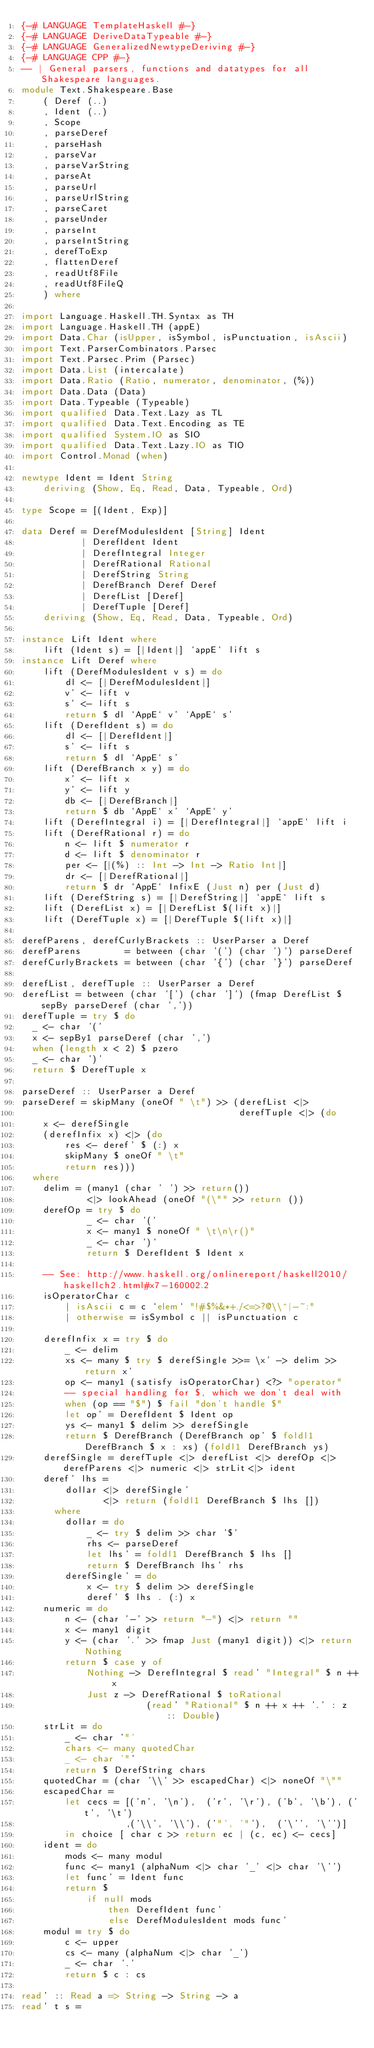<code> <loc_0><loc_0><loc_500><loc_500><_Haskell_>{-# LANGUAGE TemplateHaskell #-}
{-# LANGUAGE DeriveDataTypeable #-}
{-# LANGUAGE GeneralizedNewtypeDeriving #-}
{-# LANGUAGE CPP #-}
-- | General parsers, functions and datatypes for all Shakespeare languages.
module Text.Shakespeare.Base
    ( Deref (..)
    , Ident (..)
    , Scope
    , parseDeref
    , parseHash
    , parseVar
    , parseVarString
    , parseAt
    , parseUrl
    , parseUrlString
    , parseCaret
    , parseUnder
    , parseInt
    , parseIntString
    , derefToExp
    , flattenDeref
    , readUtf8File
    , readUtf8FileQ
    ) where

import Language.Haskell.TH.Syntax as TH
import Language.Haskell.TH (appE)
import Data.Char (isUpper, isSymbol, isPunctuation, isAscii)
import Text.ParserCombinators.Parsec
import Text.Parsec.Prim (Parsec)
import Data.List (intercalate)
import Data.Ratio (Ratio, numerator, denominator, (%))
import Data.Data (Data)
import Data.Typeable (Typeable)
import qualified Data.Text.Lazy as TL
import qualified Data.Text.Encoding as TE
import qualified System.IO as SIO
import qualified Data.Text.Lazy.IO as TIO
import Control.Monad (when)

newtype Ident = Ident String
    deriving (Show, Eq, Read, Data, Typeable, Ord)

type Scope = [(Ident, Exp)]

data Deref = DerefModulesIdent [String] Ident
           | DerefIdent Ident
           | DerefIntegral Integer
           | DerefRational Rational
           | DerefString String
           | DerefBranch Deref Deref
           | DerefList [Deref]
           | DerefTuple [Deref]
    deriving (Show, Eq, Read, Data, Typeable, Ord)

instance Lift Ident where
    lift (Ident s) = [|Ident|] `appE` lift s
instance Lift Deref where
    lift (DerefModulesIdent v s) = do
        dl <- [|DerefModulesIdent|]
        v' <- lift v
        s' <- lift s
        return $ dl `AppE` v' `AppE` s'
    lift (DerefIdent s) = do
        dl <- [|DerefIdent|]
        s' <- lift s
        return $ dl `AppE` s'
    lift (DerefBranch x y) = do
        x' <- lift x
        y' <- lift y
        db <- [|DerefBranch|]
        return $ db `AppE` x' `AppE` y'
    lift (DerefIntegral i) = [|DerefIntegral|] `appE` lift i
    lift (DerefRational r) = do
        n <- lift $ numerator r
        d <- lift $ denominator r
        per <- [|(%) :: Int -> Int -> Ratio Int|]
        dr <- [|DerefRational|]
        return $ dr `AppE` InfixE (Just n) per (Just d)
    lift (DerefString s) = [|DerefString|] `appE` lift s
    lift (DerefList x) = [|DerefList $(lift x)|]
    lift (DerefTuple x) = [|DerefTuple $(lift x)|]

derefParens, derefCurlyBrackets :: UserParser a Deref
derefParens        = between (char '(') (char ')') parseDeref
derefCurlyBrackets = between (char '{') (char '}') parseDeref

derefList, derefTuple :: UserParser a Deref
derefList = between (char '[') (char ']') (fmap DerefList $ sepBy parseDeref (char ','))
derefTuple = try $ do
  _ <- char '('
  x <- sepBy1 parseDeref (char ',')
  when (length x < 2) $ pzero
  _ <- char ')'
  return $ DerefTuple x

parseDeref :: UserParser a Deref
parseDeref = skipMany (oneOf " \t") >> (derefList <|>
                                        derefTuple <|> (do
    x <- derefSingle
    (derefInfix x) <|> (do
        res <- deref' $ (:) x
        skipMany $ oneOf " \t"
        return res)))
  where
    delim = (many1 (char ' ') >> return())
            <|> lookAhead (oneOf "(\"" >> return ())
    derefOp = try $ do
            _ <- char '('
            x <- many1 $ noneOf " \t\n\r()"
            _ <- char ')'
            return $ DerefIdent $ Ident x

    -- See: http://www.haskell.org/onlinereport/haskell2010/haskellch2.html#x7-160002.2
    isOperatorChar c
        | isAscii c = c `elem` "!#$%&*+./<=>?@\\^|-~:"
        | otherwise = isSymbol c || isPunctuation c

    derefInfix x = try $ do
        _ <- delim
        xs <- many $ try $ derefSingle >>= \x' -> delim >> return x'
        op <- many1 (satisfy isOperatorChar) <?> "operator"
        -- special handling for $, which we don't deal with
        when (op == "$") $ fail "don't handle $"
        let op' = DerefIdent $ Ident op
        ys <- many1 $ delim >> derefSingle
        return $ DerefBranch (DerefBranch op' $ foldl1 DerefBranch $ x : xs) (foldl1 DerefBranch ys)
    derefSingle = derefTuple <|> derefList <|> derefOp <|> derefParens <|> numeric <|> strLit<|> ident
    deref' lhs =
        dollar <|> derefSingle'
               <|> return (foldl1 DerefBranch $ lhs [])
      where
        dollar = do
            _ <- try $ delim >> char '$'
            rhs <- parseDeref
            let lhs' = foldl1 DerefBranch $ lhs []
            return $ DerefBranch lhs' rhs
        derefSingle' = do
            x <- try $ delim >> derefSingle
            deref' $ lhs . (:) x
    numeric = do
        n <- (char '-' >> return "-") <|> return ""
        x <- many1 digit
        y <- (char '.' >> fmap Just (many1 digit)) <|> return Nothing
        return $ case y of
            Nothing -> DerefIntegral $ read' "Integral" $ n ++ x
            Just z -> DerefRational $ toRational
                       (read' "Rational" $ n ++ x ++ '.' : z :: Double)
    strLit = do
        _ <- char '"'
        chars <- many quotedChar
        _ <- char '"'
        return $ DerefString chars
    quotedChar = (char '\\' >> escapedChar) <|> noneOf "\""
    escapedChar =
        let cecs = [('n', '\n'),  ('r', '\r'), ('b', '\b'), ('t', '\t')
                   ,('\\', '\\'), ('"', '"'),  ('\'', '\'')]
        in choice [ char c >> return ec | (c, ec) <- cecs]
    ident = do
        mods <- many modul
        func <- many1 (alphaNum <|> char '_' <|> char '\'')
        let func' = Ident func
        return $
            if null mods
                then DerefIdent func'
                else DerefModulesIdent mods func'
    modul = try $ do
        c <- upper
        cs <- many (alphaNum <|> char '_')
        _ <- char '.'
        return $ c : cs

read' :: Read a => String -> String -> a
read' t s =</code> 